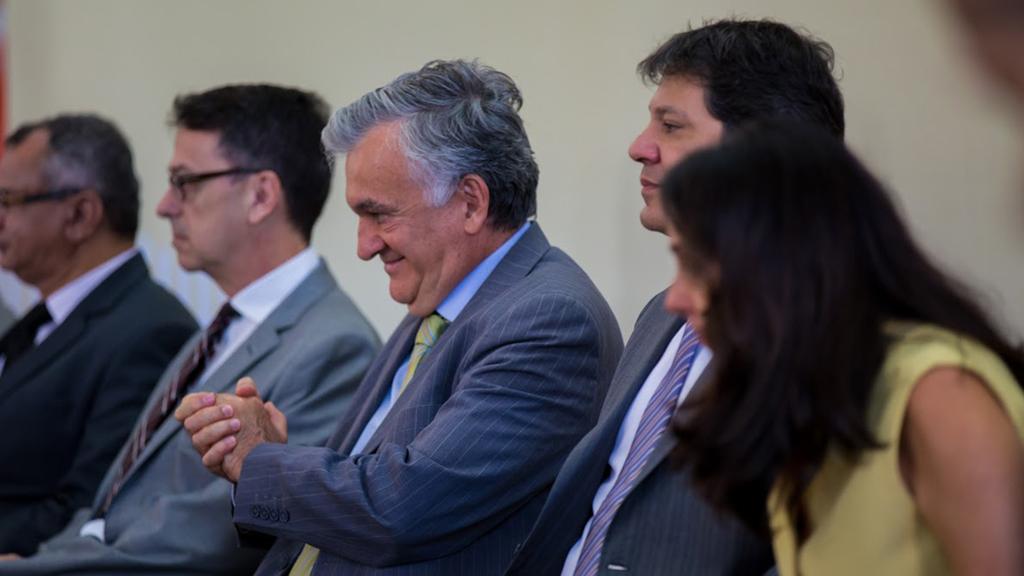Can you describe this image briefly? In this image in the foreground there are few people who are sitting and one person is smiling, and in the background there is a wall. 